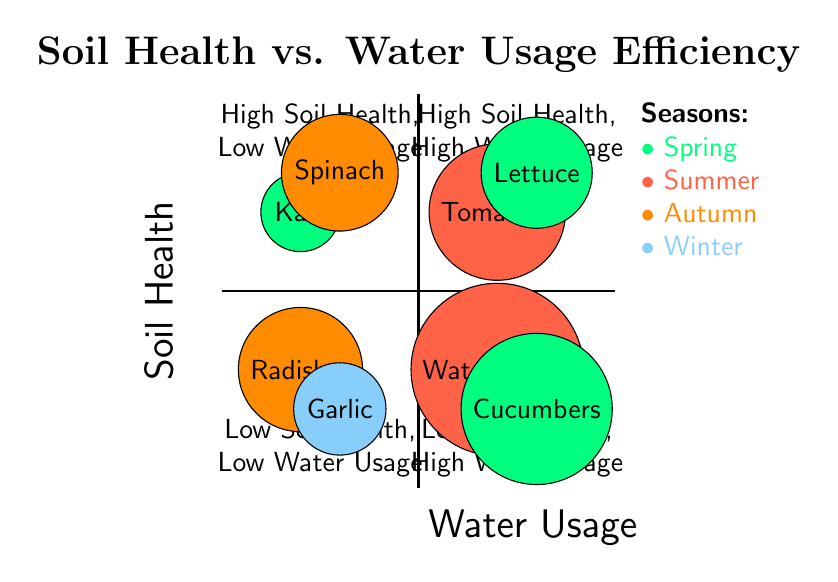What crops are in the "High Soil Health, Low Water Usage" quadrant? The "High Soil Health, Low Water Usage" quadrant includes two crops: Kale and Spinach. These crops are specifically mentioned under this quadrant in the diagram.
Answer: Kale, Spinach Which season has crops in the "Low Soil Health, High Water Usage" quadrant? In the "Low Soil Health, High Water Usage" quadrant, the crops listed are Watermelons and Cucumbers, both of which are associated with the Spring and Summer seasons, respectively.
Answer: Summer How many crops are present in the "Low Soil Health, Low Water Usage" quadrant? The "Low Soil Health, Low Water Usage" quadrant contains two crops: Radishes and Garlic. Thus, the total number of crops in this quadrant is two.
Answer: 2 What is the total number of quadrants represented in the diagram? The diagram shows four distinct quadrants: High Soil Health, Low Water Usage; High Soil Health, High Water Usage; Low Soil Health, Low Water Usage; and Low Soil Health, High Water Usage. This counts to a total of four quadrants.
Answer: 4 What crop appears in both the "High Soil Health, High Water Usage" and "Low Soil Health, High Water Usage" quadrants? Upon reviewing the crops in the quadrants with high water usage, there are no crops that appear in both quadrants; Tomatoes and Lettuce belong to the High Soil Health, High Water Usage quadrant, while Watermelons and Cucumbers belong to the Low Soil Health, High Water Usage quadrant. Thus, none of the crops overlap.
Answer: None 